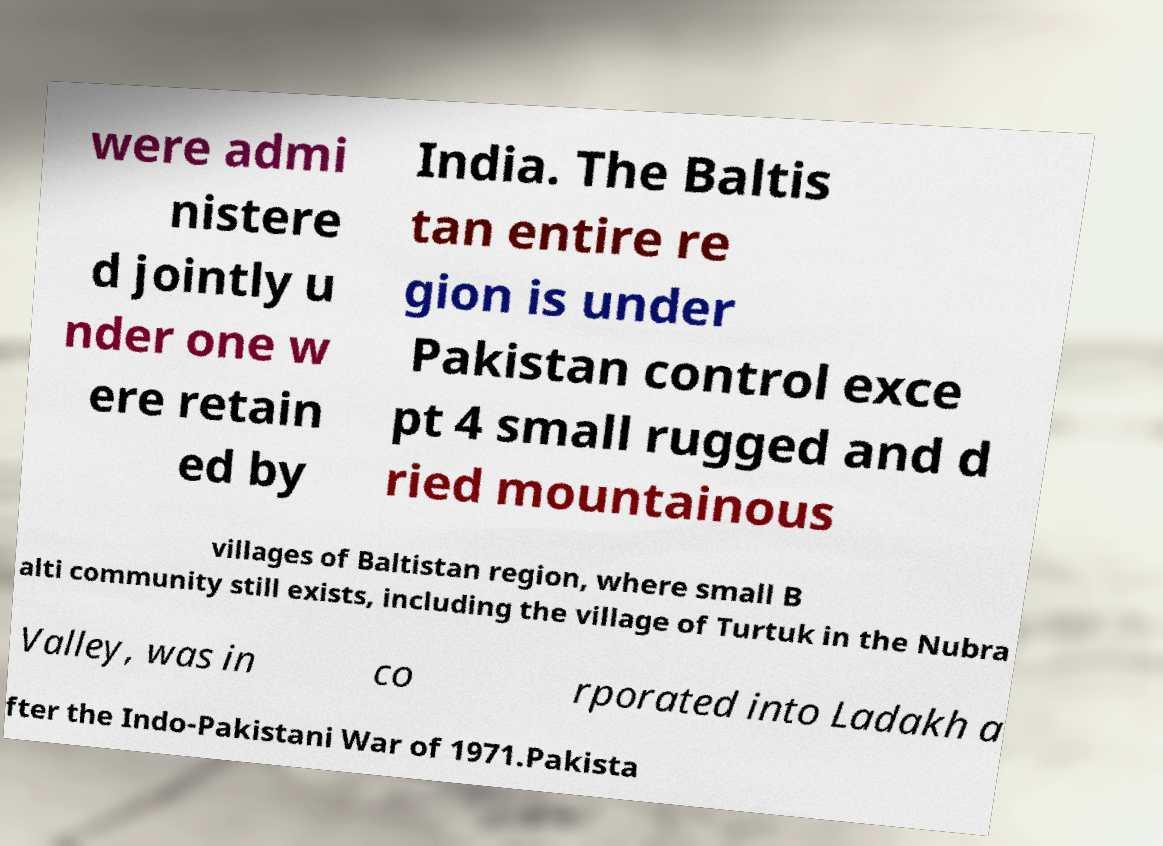Please identify and transcribe the text found in this image. were admi nistere d jointly u nder one w ere retain ed by India. The Baltis tan entire re gion is under Pakistan control exce pt 4 small rugged and d ried mountainous villages of Baltistan region, where small B alti community still exists, including the village of Turtuk in the Nubra Valley, was in co rporated into Ladakh a fter the Indo-Pakistani War of 1971.Pakista 